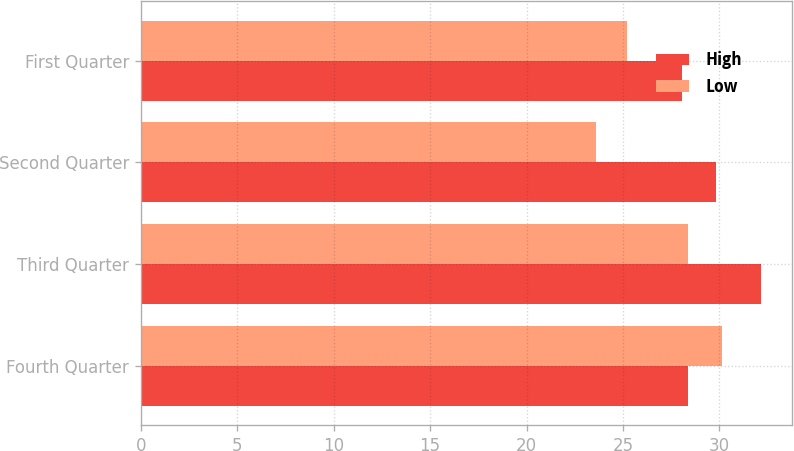<chart> <loc_0><loc_0><loc_500><loc_500><stacked_bar_chart><ecel><fcel>Fourth Quarter<fcel>Third Quarter<fcel>Second Quarter<fcel>First Quarter<nl><fcel>High<fcel>28.38<fcel>32.17<fcel>29.81<fcel>28.05<nl><fcel>Low<fcel>30.15<fcel>28.38<fcel>23.6<fcel>25.21<nl></chart> 